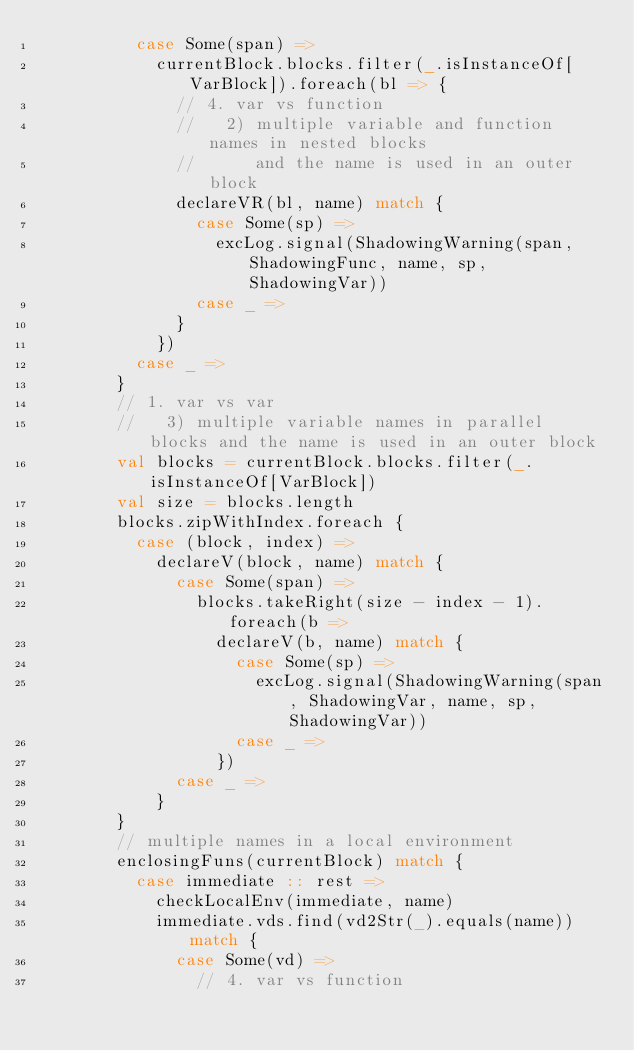<code> <loc_0><loc_0><loc_500><loc_500><_Scala_>          case Some(span) =>
            currentBlock.blocks.filter(_.isInstanceOf[VarBlock]).foreach(bl => {
              // 4. var vs function
              //   2) multiple variable and function names in nested blocks
              //      and the name is used in an outer block
              declareVR(bl, name) match {
                case Some(sp) =>
                  excLog.signal(ShadowingWarning(span, ShadowingFunc, name, sp, ShadowingVar))
                case _ =>
              }
            })
          case _ =>
        }
        // 1. var vs var
        //   3) multiple variable names in parallel blocks and the name is used in an outer block
        val blocks = currentBlock.blocks.filter(_.isInstanceOf[VarBlock])
        val size = blocks.length
        blocks.zipWithIndex.foreach {
          case (block, index) =>
            declareV(block, name) match {
              case Some(span) =>
                blocks.takeRight(size - index - 1).foreach(b =>
                  declareV(b, name) match {
                    case Some(sp) =>
                      excLog.signal(ShadowingWarning(span, ShadowingVar, name, sp, ShadowingVar))
                    case _ =>
                  })
              case _ =>
            }
        }
        // multiple names in a local environment
        enclosingFuns(currentBlock) match {
          case immediate :: rest =>
            checkLocalEnv(immediate, name)
            immediate.vds.find(vd2Str(_).equals(name)) match {
              case Some(vd) =>
                // 4. var vs function</code> 